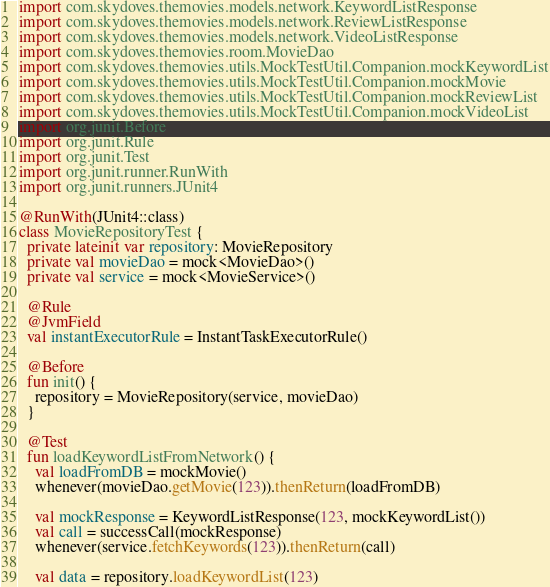Convert code to text. <code><loc_0><loc_0><loc_500><loc_500><_Kotlin_>import com.skydoves.themovies.models.network.KeywordListResponse
import com.skydoves.themovies.models.network.ReviewListResponse
import com.skydoves.themovies.models.network.VideoListResponse
import com.skydoves.themovies.room.MovieDao
import com.skydoves.themovies.utils.MockTestUtil.Companion.mockKeywordList
import com.skydoves.themovies.utils.MockTestUtil.Companion.mockMovie
import com.skydoves.themovies.utils.MockTestUtil.Companion.mockReviewList
import com.skydoves.themovies.utils.MockTestUtil.Companion.mockVideoList
import org.junit.Before
import org.junit.Rule
import org.junit.Test
import org.junit.runner.RunWith
import org.junit.runners.JUnit4

@RunWith(JUnit4::class)
class MovieRepositoryTest {
  private lateinit var repository: MovieRepository
  private val movieDao = mock<MovieDao>()
  private val service = mock<MovieService>()

  @Rule
  @JvmField
  val instantExecutorRule = InstantTaskExecutorRule()

  @Before
  fun init() {
    repository = MovieRepository(service, movieDao)
  }

  @Test
  fun loadKeywordListFromNetwork() {
    val loadFromDB = mockMovie()
    whenever(movieDao.getMovie(123)).thenReturn(loadFromDB)

    val mockResponse = KeywordListResponse(123, mockKeywordList())
    val call = successCall(mockResponse)
    whenever(service.fetchKeywords(123)).thenReturn(call)

    val data = repository.loadKeywordList(123)</code> 